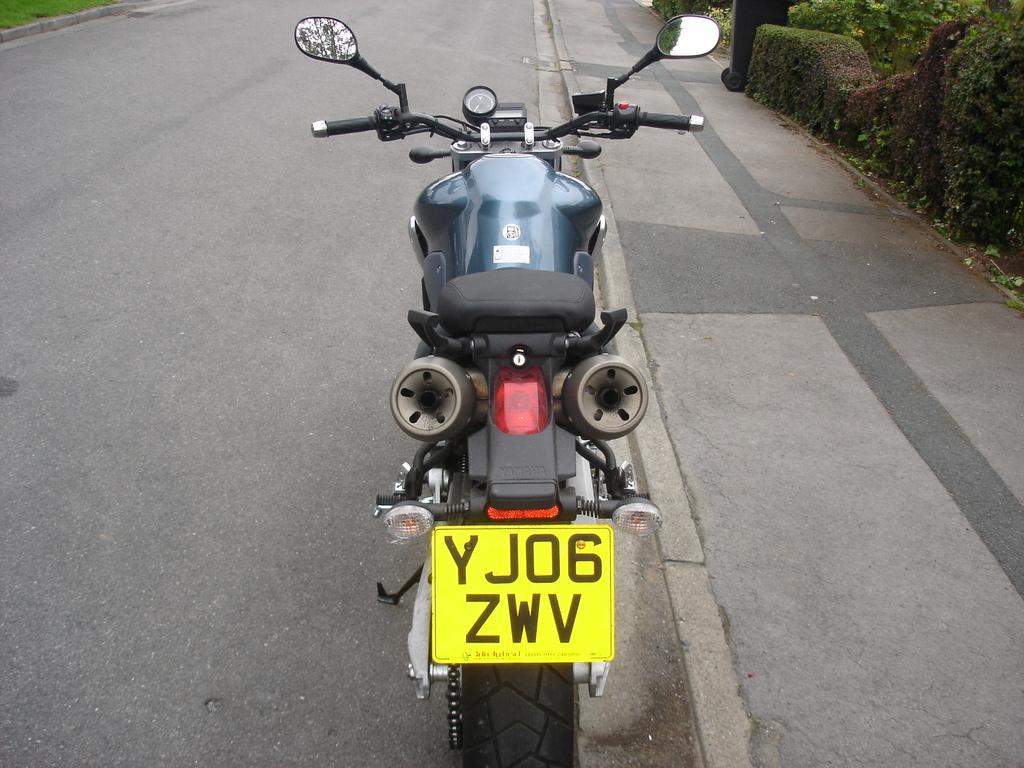Describe this image in one or two sentences. In front of the picture, we see a bike. At the bottom of the picture, we see the road. In the right top of the picture, we see trees and shrubs. 